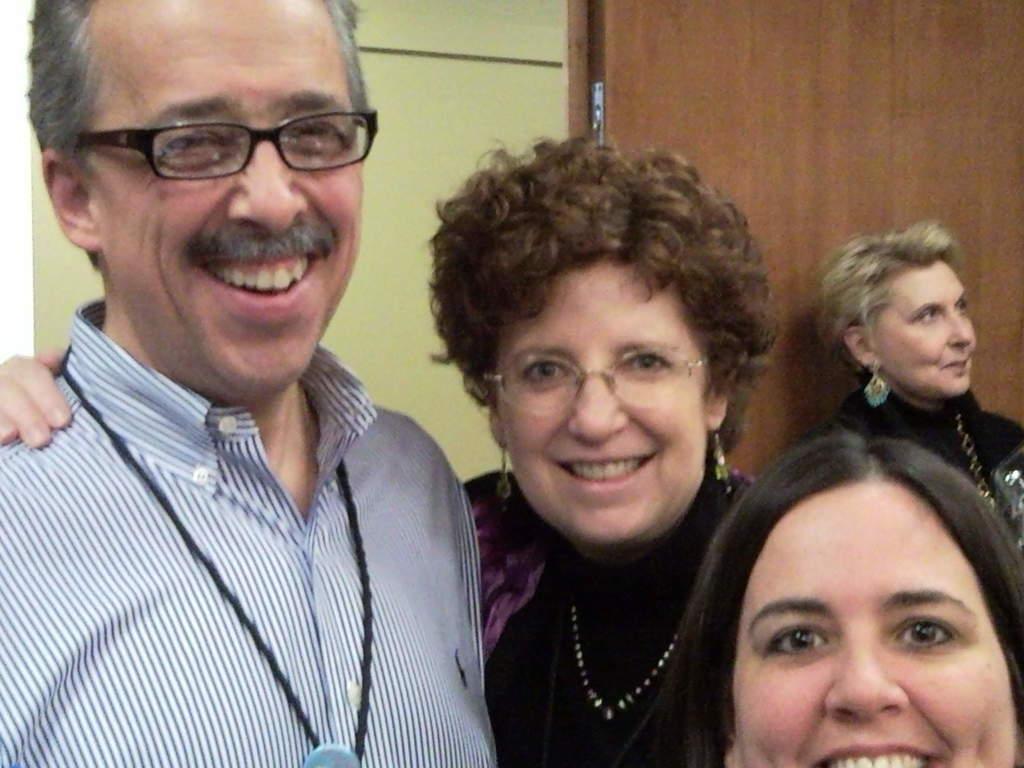Please provide a concise description of this image. In this image there are a few people standing with a smile on their face, behind them there is a lady looking at the right side of the image. In the background there is a wall and a door. 